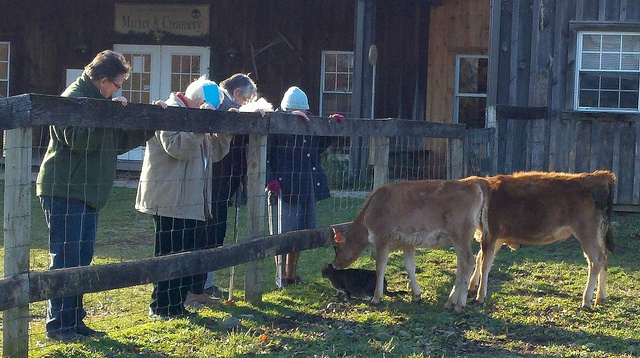Describe the objects in this image and their specific colors. I can see people in black, navy, purple, and gray tones, cow in black and gray tones, cow in black, gray, and maroon tones, people in black, gray, white, and darkgray tones, and people in black, navy, gray, and darkblue tones in this image. 